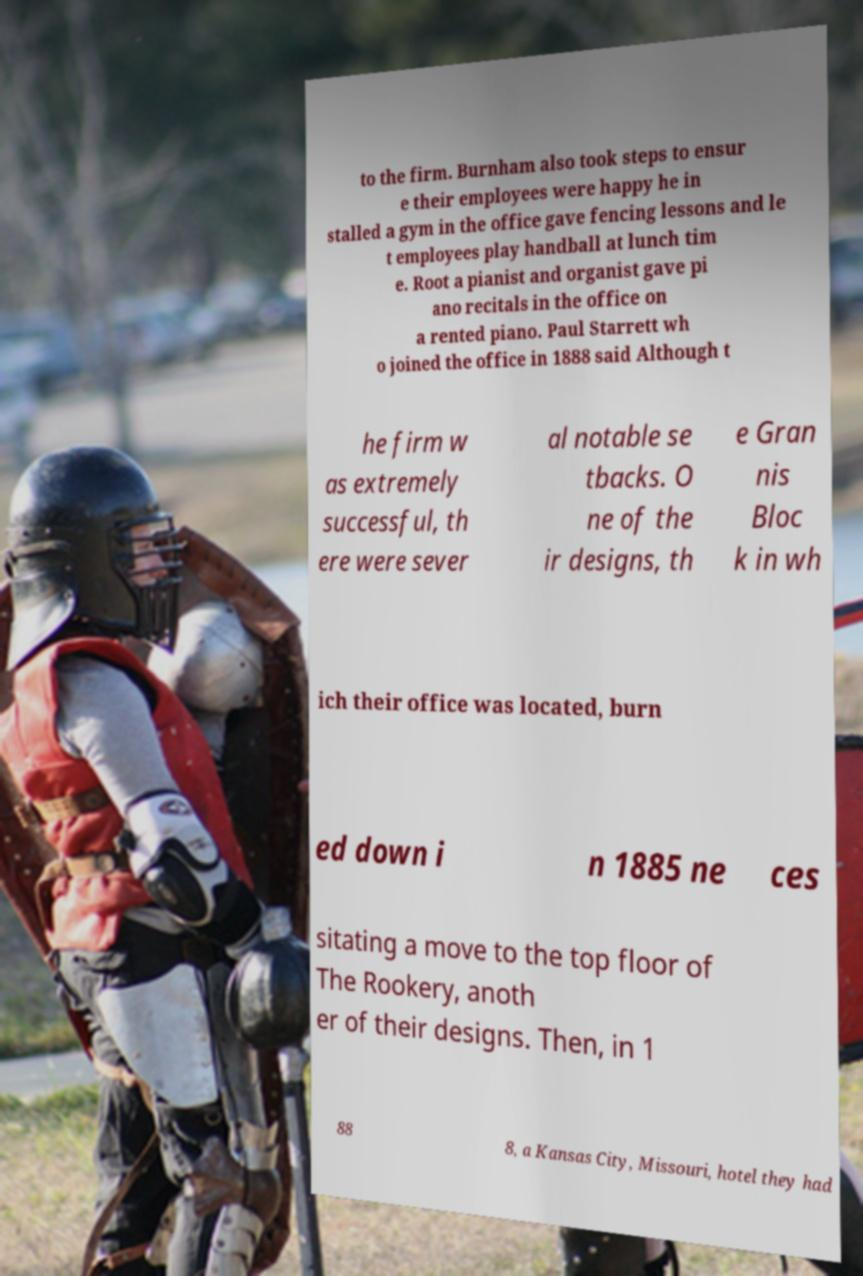There's text embedded in this image that I need extracted. Can you transcribe it verbatim? to the firm. Burnham also took steps to ensur e their employees were happy he in stalled a gym in the office gave fencing lessons and le t employees play handball at lunch tim e. Root a pianist and organist gave pi ano recitals in the office on a rented piano. Paul Starrett wh o joined the office in 1888 said Although t he firm w as extremely successful, th ere were sever al notable se tbacks. O ne of the ir designs, th e Gran nis Bloc k in wh ich their office was located, burn ed down i n 1885 ne ces sitating a move to the top floor of The Rookery, anoth er of their designs. Then, in 1 88 8, a Kansas City, Missouri, hotel they had 